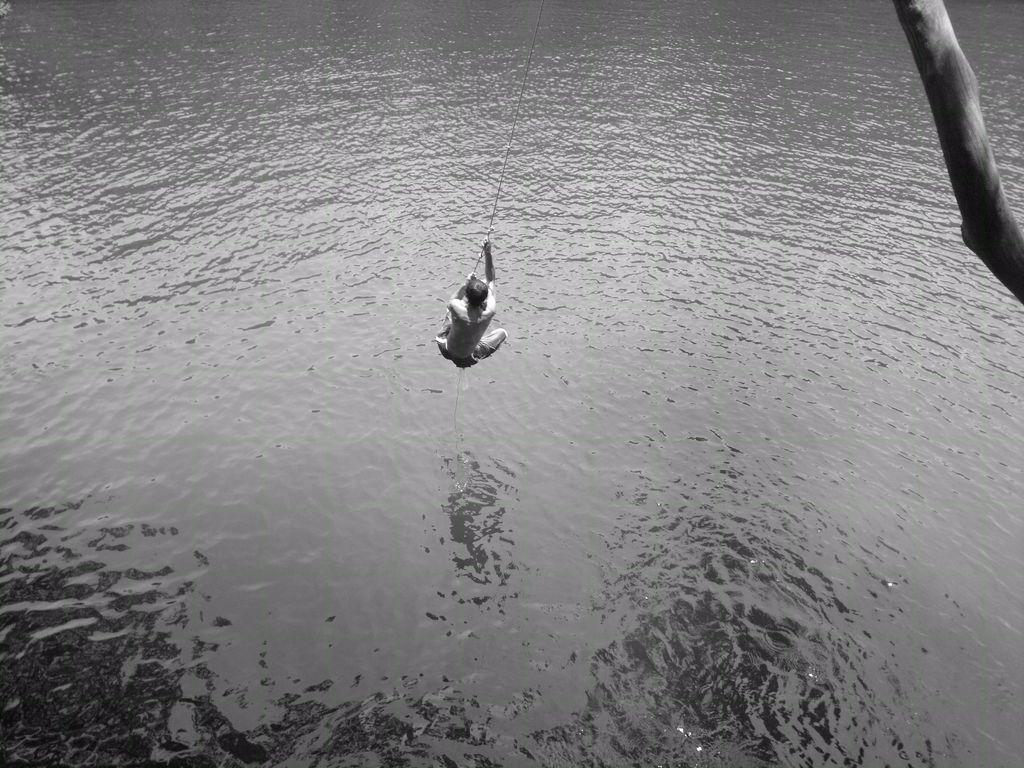What is the main subject of the picture? The main subject of the picture is a man. What is the man holding in the image? The man is holding a rope. What is the man doing in the picture? The man is swinging. What can be seen in the background of the image? There is water visible in the image. What is present on the right side of the picture? There is a branch of a tree on the right side of the picture. How many pigs are playing volleyball in the image? There are no pigs or volleyball present in the image. What type of needle is being used by the man in the image? There is no needle present in the image; the man is holding a rope and swinging. 